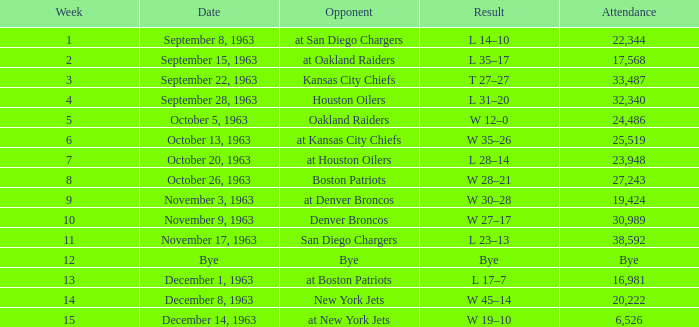Which adversary has a date of november 17, 1963? San Diego Chargers. 